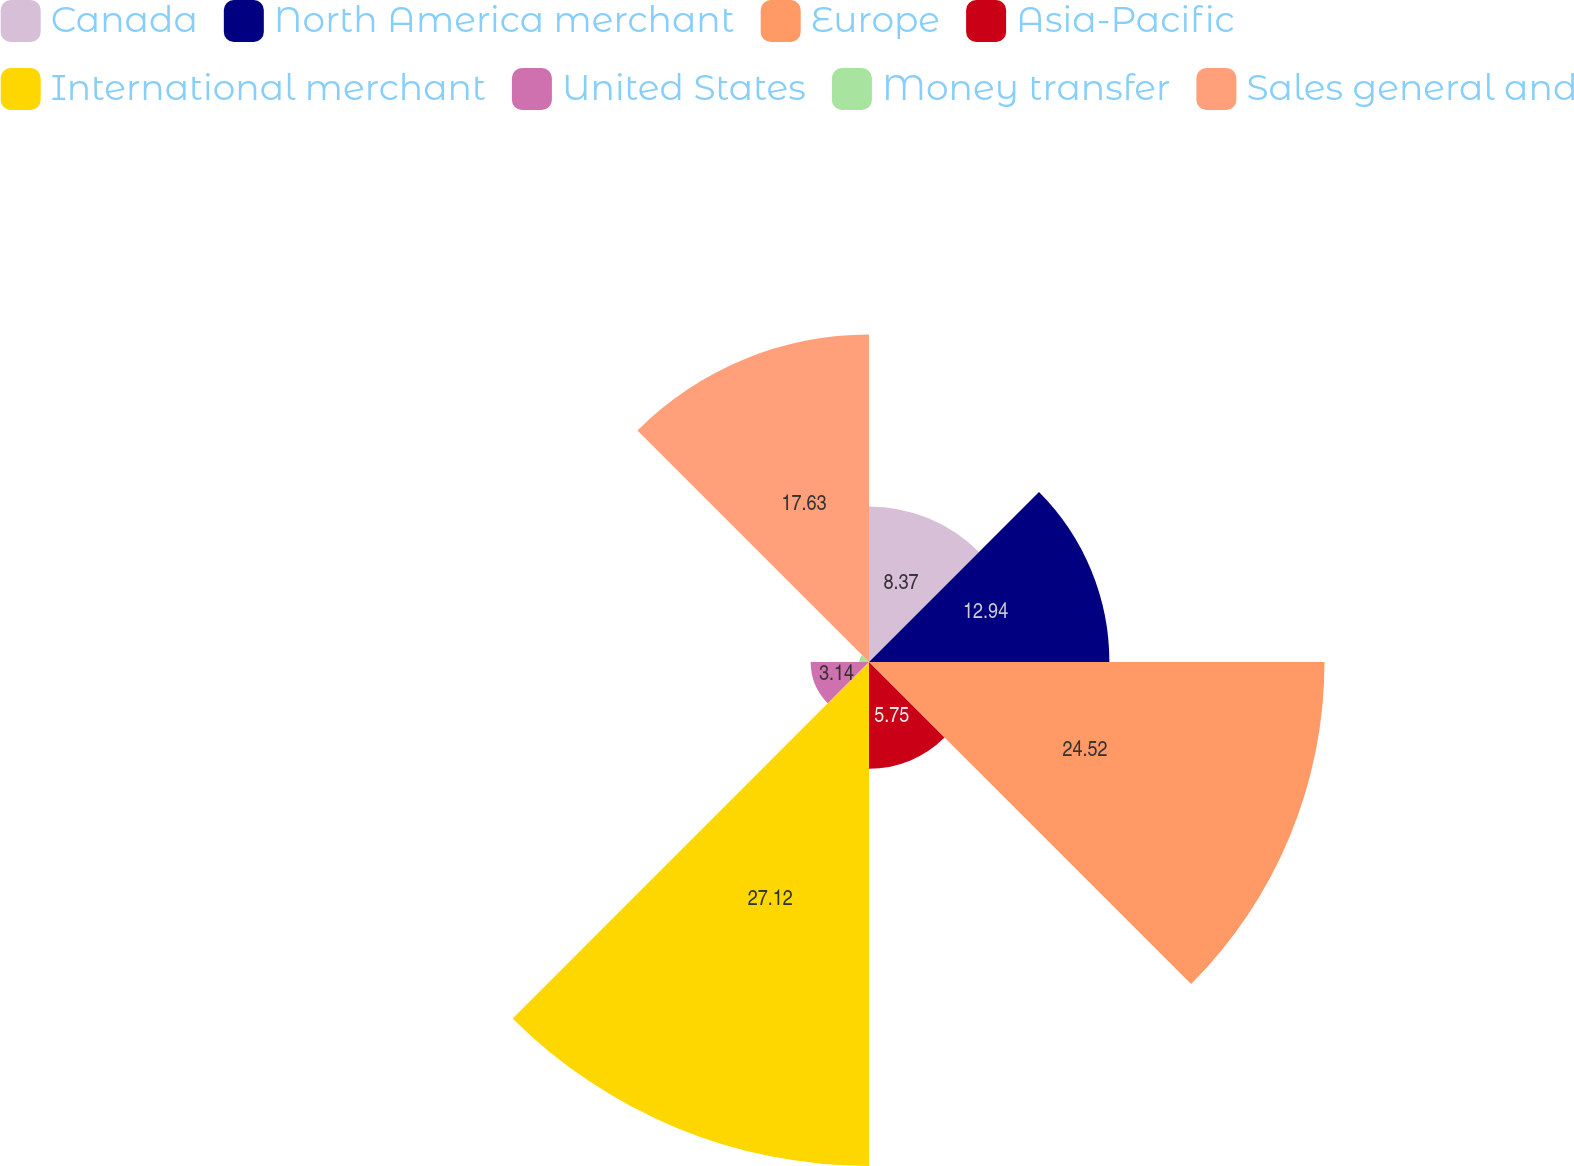Convert chart. <chart><loc_0><loc_0><loc_500><loc_500><pie_chart><fcel>Canada<fcel>North America merchant<fcel>Europe<fcel>Asia-Pacific<fcel>International merchant<fcel>United States<fcel>Money transfer<fcel>Sales general and<nl><fcel>8.37%<fcel>12.94%<fcel>24.52%<fcel>5.75%<fcel>27.13%<fcel>3.14%<fcel>0.53%<fcel>17.63%<nl></chart> 